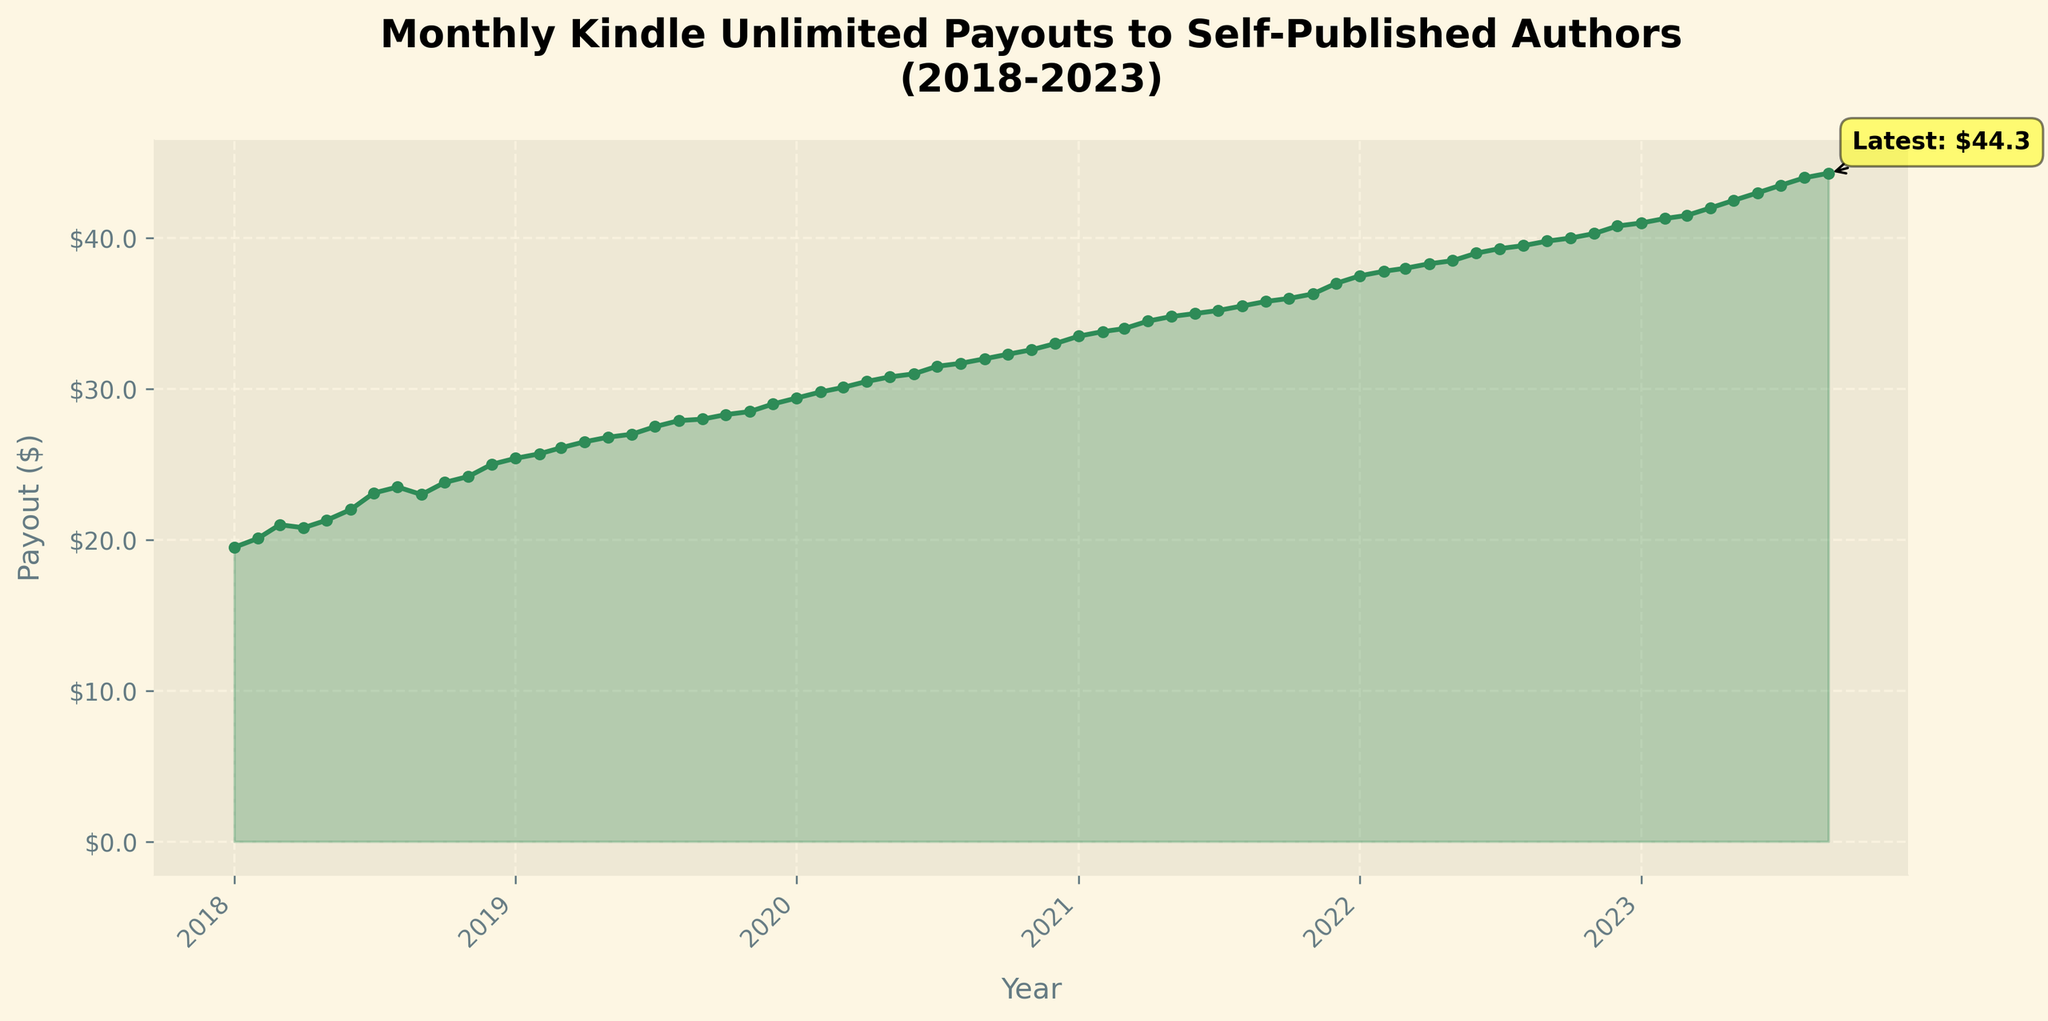What is the title of the plot? The title of the plot is the text displayed at the top and it reads "Monthly Kindle Unlimited Payouts to Self-Published Authors (2018-2023)."
Answer: Monthly Kindle Unlimited Payouts to Self-Published Authors (2018-2023) What color is used for the line graph representing payouts? The color of the line graph can be identified by visually inspecting the plot. The line is green.
Answer: Green How many years are represented on the x-axis? The x-axis has labels showing each year from 2018 to 2023. By counting the distinct year labels, we can see that six years are represented.
Answer: Six What is the value of the latest payout? The latest payout can be found by looking at the annotated point on the right end of the line graph. It shows 'Latest: $44.3'.
Answer: $44.3 What is the highest payout achieved over the 5-year period? The highest payout value corresponds to the peak at the rightmost end of the plot, which is annotated as $44.3.
Answer: $44.3 What was the payout in January 2020? To find the payout in January 2020, look for the point that aligns with January 2020 on the x-axis. The corresponding payout value in the plot is $29.4.
Answer: $29.4 How much did the payout increase from January 2018 to January 2023? Subtract the payout value in January 2018 ($19.5) from the payout value in January 2023 ($41.0) to find the increase: $41.0 - $19.5 = $21.5.
Answer: $21.5 Which year saw the biggest increase in payout from January to December? Calculate the difference between the December and January payouts for each year and compare them. The 2020 increase is $33.0 - $29.4 = $3.6, and other yearly increases are smaller. Therefore, 2020 had the largest increase.
Answer: 2020 Was there any month where the payout did not increase compared to the previous month? Visually inspect each month-to-month connection in the plot. There are no significant drops or straight lines indicating a decline or stagnation, implying the payouts consistently increased every month.
Answer: No 